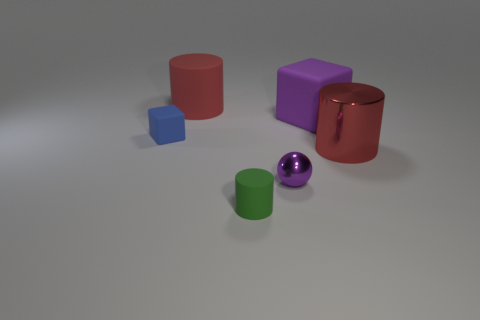Subtract all red cylinders. How many cylinders are left? 1 Subtract all purple blocks. How many blocks are left? 1 Add 3 large cylinders. How many objects exist? 9 Subtract all cubes. How many objects are left? 4 Subtract 1 cubes. How many cubes are left? 1 Subtract all cyan cylinders. How many purple blocks are left? 1 Subtract all large gray metallic balls. Subtract all red cylinders. How many objects are left? 4 Add 6 purple things. How many purple things are left? 8 Add 1 small spheres. How many small spheres exist? 2 Subtract 0 cyan cubes. How many objects are left? 6 